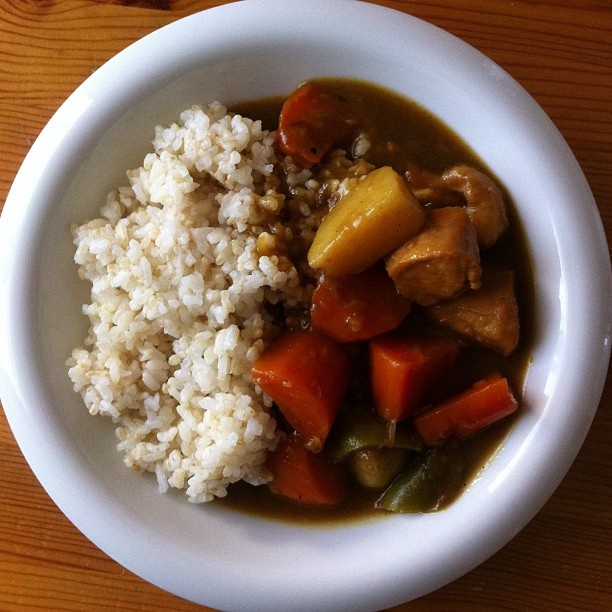Describe the objects in this image and their specific colors. I can see dining table in black, maroon, lightgray, darkgray, and gray tones, bowl in red, lightgray, black, maroon, and darkgray tones, carrot in red, black, maroon, and brown tones, and carrot in red and maroon tones in this image. 